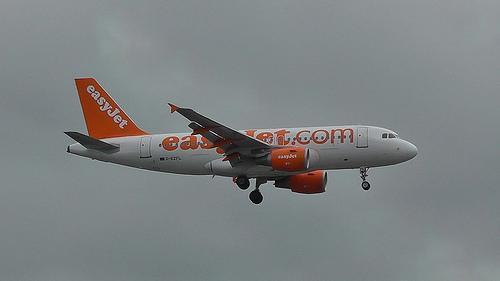How many planes are there?
Give a very brief answer. 1. 